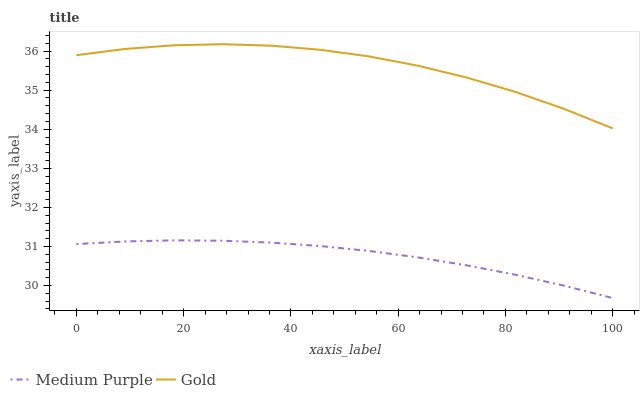Does Gold have the minimum area under the curve?
Answer yes or no. No. Is Gold the smoothest?
Answer yes or no. No. Does Gold have the lowest value?
Answer yes or no. No. Is Medium Purple less than Gold?
Answer yes or no. Yes. Is Gold greater than Medium Purple?
Answer yes or no. Yes. Does Medium Purple intersect Gold?
Answer yes or no. No. 